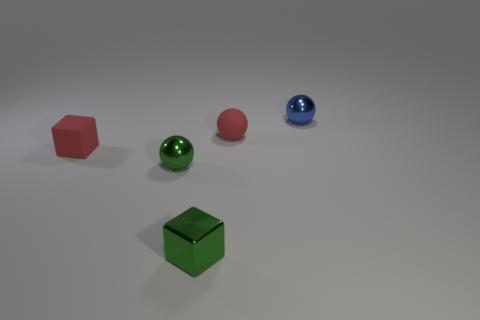How many brown objects are either small metal blocks or cubes?
Make the answer very short. 0. Are there any other things that have the same material as the blue object?
Provide a short and direct response. Yes. Are the small cube to the right of the red matte block and the red cube made of the same material?
Offer a terse response. No. How many things are small red blocks or small spheres behind the small red matte block?
Ensure brevity in your answer.  3. There is a tiny ball right of the small red rubber ball that is behind the red rubber block; what number of red spheres are on the left side of it?
Offer a very short reply. 1. Do the tiny red thing that is to the right of the small red cube and the blue object have the same shape?
Your response must be concise. Yes. There is a small green metallic object on the right side of the tiny green metal ball; is there a blue metallic sphere that is in front of it?
Offer a terse response. No. How many tiny red cubes are there?
Ensure brevity in your answer.  1. There is a small ball that is both on the left side of the small blue metal object and behind the tiny red cube; what is its color?
Ensure brevity in your answer.  Red. There is a green metal object that is the same shape as the blue shiny thing; what size is it?
Offer a terse response. Small. 